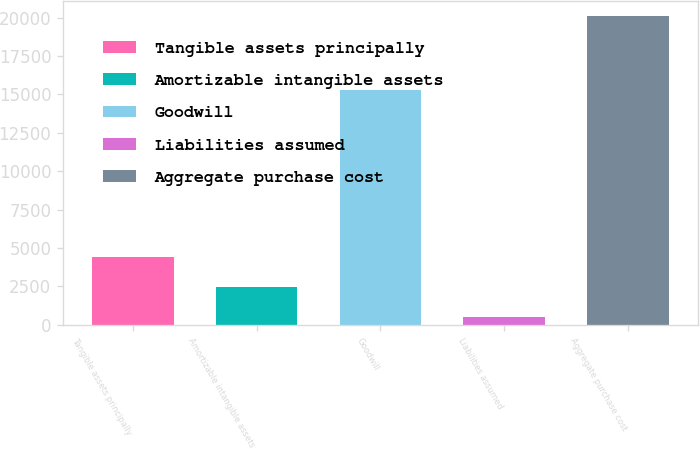<chart> <loc_0><loc_0><loc_500><loc_500><bar_chart><fcel>Tangible assets principally<fcel>Amortizable intangible assets<fcel>Goodwill<fcel>Liabilities assumed<fcel>Aggregate purchase cost<nl><fcel>4429.8<fcel>2473.9<fcel>15260<fcel>518<fcel>20077<nl></chart> 